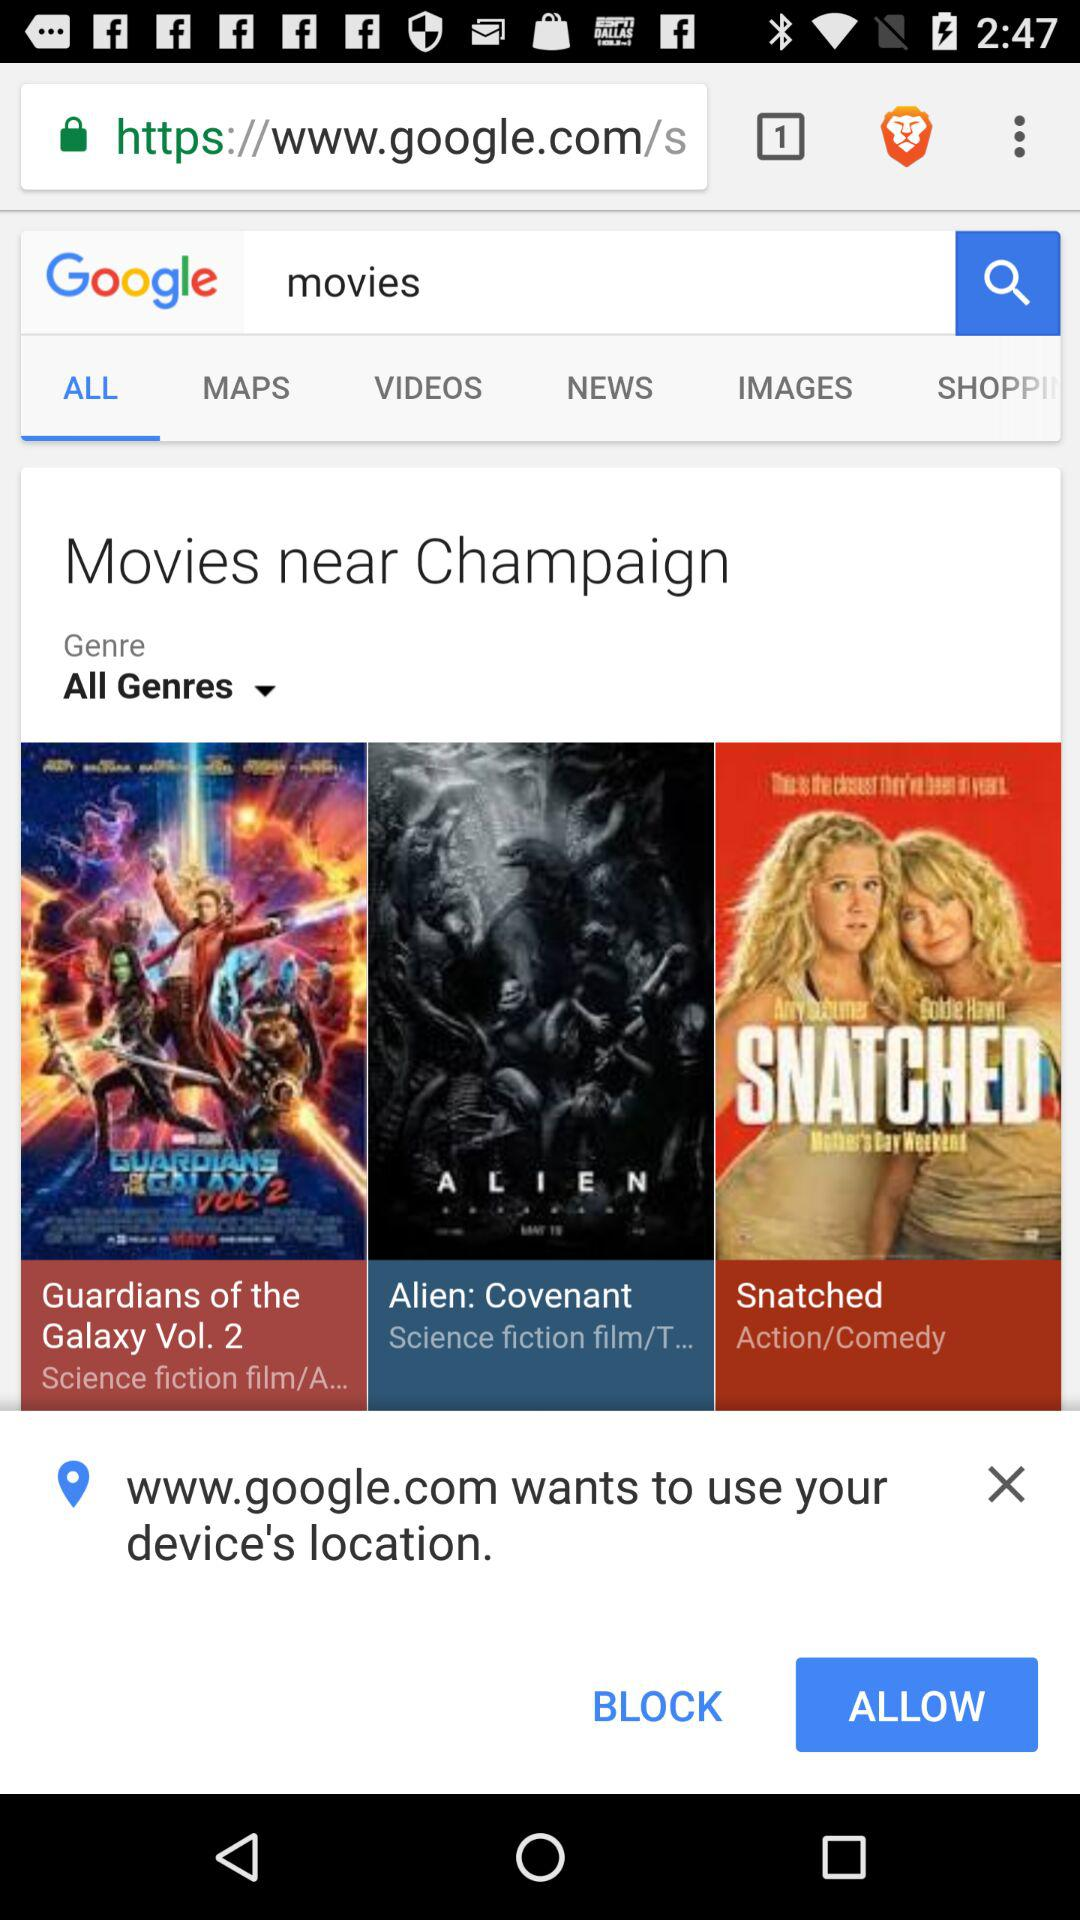What is written in the search box? The written keyword in the search box is "movies". 